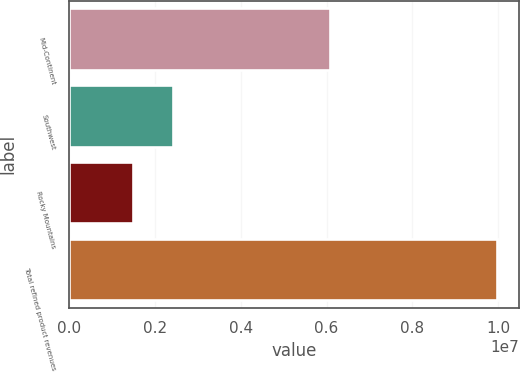Convert chart to OTSL. <chart><loc_0><loc_0><loc_500><loc_500><bar_chart><fcel>Mid-Continent<fcel>Southwest<fcel>Rocky Mountains<fcel>Total refined product revenues<nl><fcel>6.07763e+06<fcel>2.42576e+06<fcel>1.48181e+06<fcel>9.98521e+06<nl></chart> 